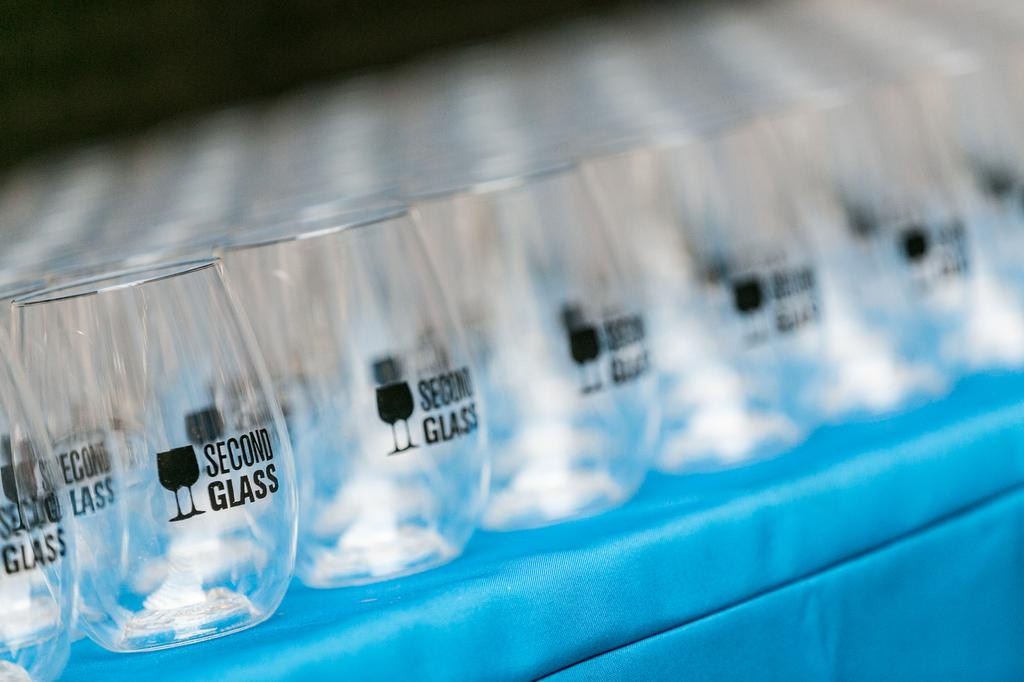<image>
Write a terse but informative summary of the picture. Multiple glasses with the name Second Glass wrote on the front. 